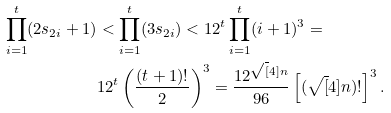Convert formula to latex. <formula><loc_0><loc_0><loc_500><loc_500>\prod _ { i = 1 } ^ { t } ( 2 s _ { 2 i } + 1 ) & < \prod _ { i = 1 } ^ { t } ( 3 s _ { 2 i } ) < 1 2 ^ { t } \prod _ { i = 1 } ^ { t } ( i + 1 ) ^ { 3 } = \\ & 1 2 ^ { t } \left ( \frac { ( t + 1 ) ! } { 2 } \right ) ^ { 3 } = \frac { 1 2 ^ { \sqrt { [ } 4 ] n } } { 9 6 } \left [ ( { \sqrt { [ } 4 ] n } ) ! \right ] ^ { 3 } .</formula> 